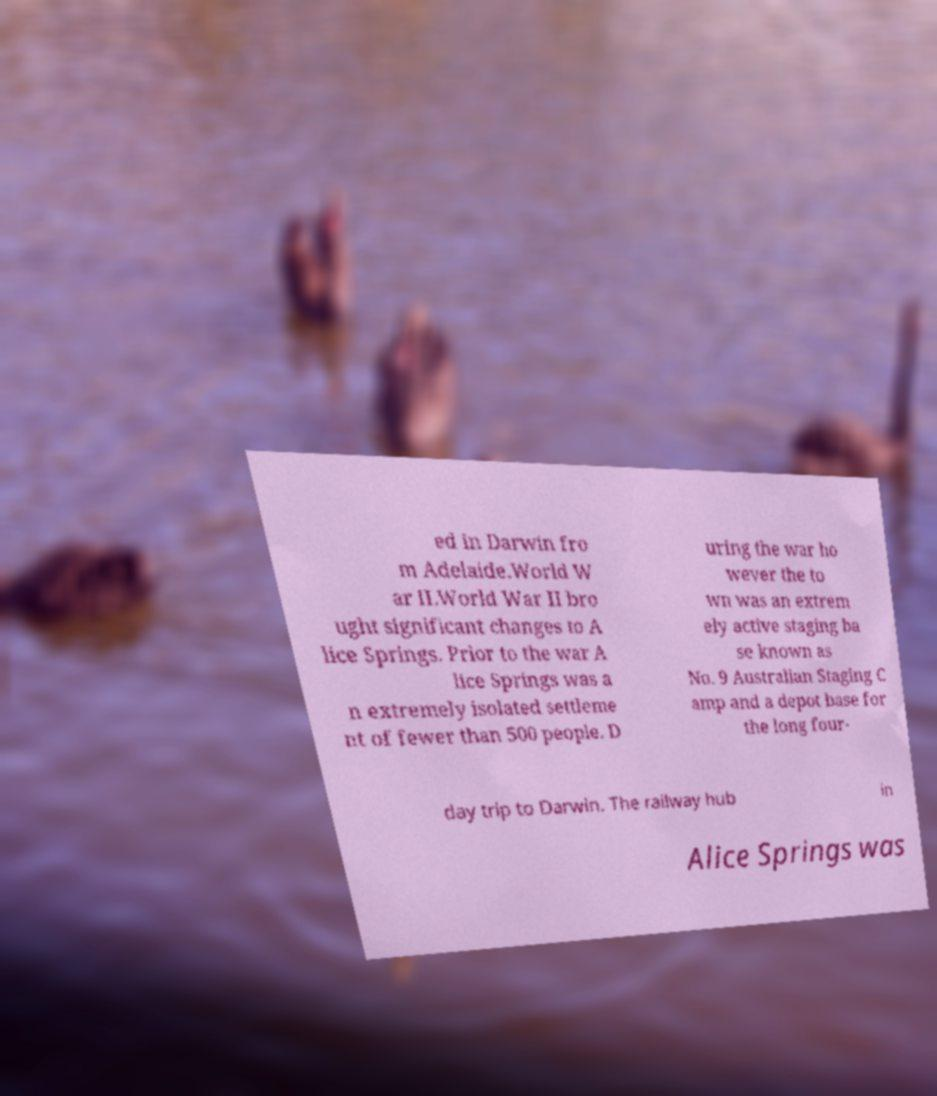For documentation purposes, I need the text within this image transcribed. Could you provide that? ed in Darwin fro m Adelaide.World W ar II.World War II bro ught significant changes to A lice Springs. Prior to the war A lice Springs was a n extremely isolated settleme nt of fewer than 500 people. D uring the war ho wever the to wn was an extrem ely active staging ba se known as No. 9 Australian Staging C amp and a depot base for the long four- day trip to Darwin. The railway hub in Alice Springs was 